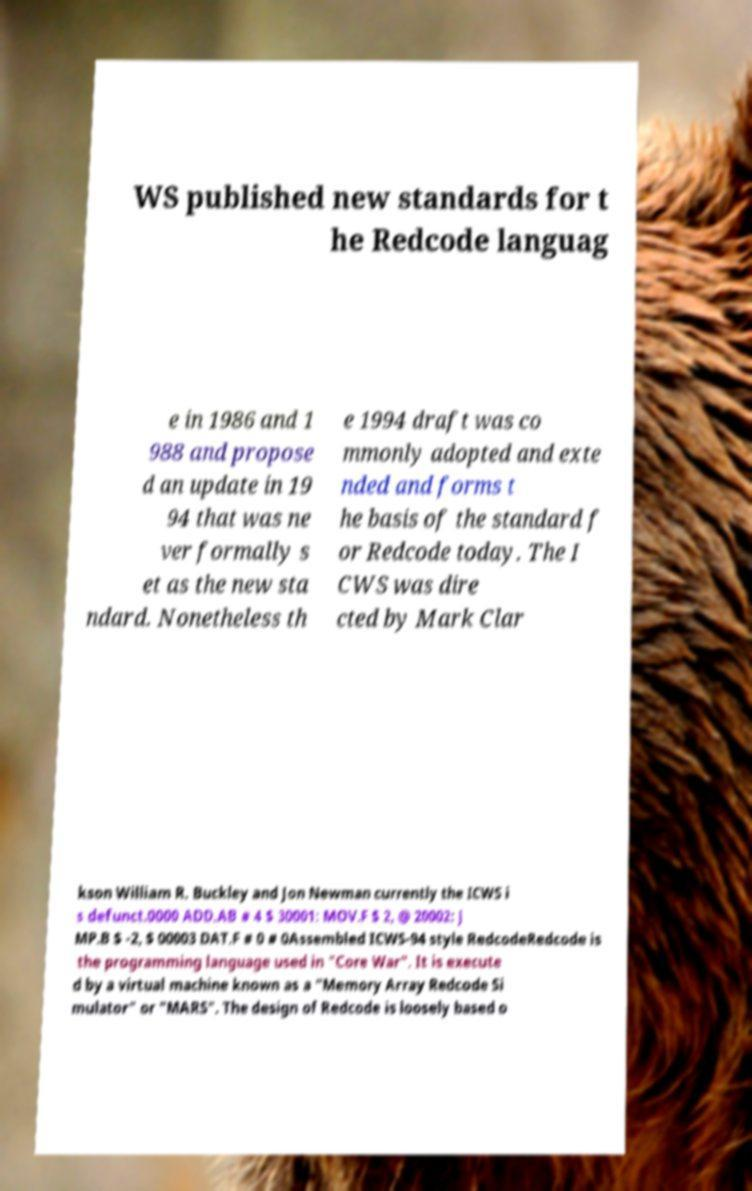There's text embedded in this image that I need extracted. Can you transcribe it verbatim? WS published new standards for t he Redcode languag e in 1986 and 1 988 and propose d an update in 19 94 that was ne ver formally s et as the new sta ndard. Nonetheless th e 1994 draft was co mmonly adopted and exte nded and forms t he basis of the standard f or Redcode today. The I CWS was dire cted by Mark Clar kson William R. Buckley and Jon Newman currently the ICWS i s defunct.0000 ADD.AB # 4 $ 30001: MOV.F $ 2, @ 20002: J MP.B $ -2, $ 00003 DAT.F # 0 # 0Assembled ICWS-94 style RedcodeRedcode is the programming language used in "Core War". It is execute d by a virtual machine known as a "Memory Array Redcode Si mulator" or "MARS". The design of Redcode is loosely based o 